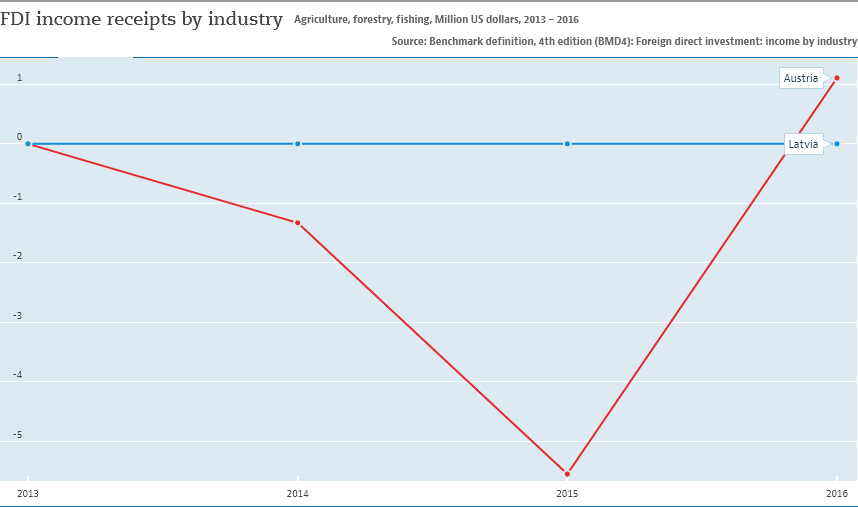List a handful of essential elements in this visual. The gap between two countries becomes largest in 2015. Latvia is represented by the blue line in the country. 